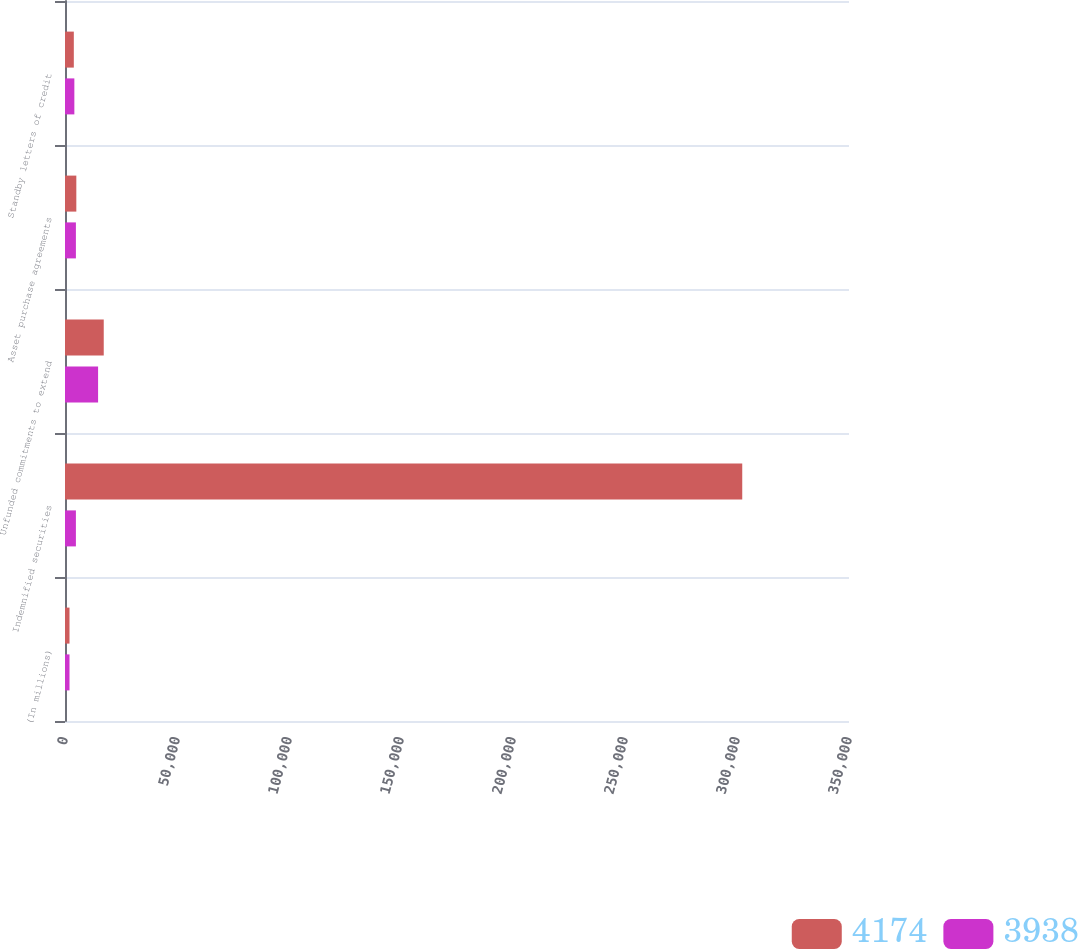<chart> <loc_0><loc_0><loc_500><loc_500><stacked_bar_chart><ecel><fcel>(In millions)<fcel>Indemnified securities<fcel>Unfunded commitments to extend<fcel>Asset purchase agreements<fcel>Standby letters of credit<nl><fcel>4174<fcel>2011<fcel>302342<fcel>17297<fcel>5056<fcel>3938<nl><fcel>3938<fcel>2010<fcel>4866<fcel>14772<fcel>4866<fcel>4174<nl></chart> 